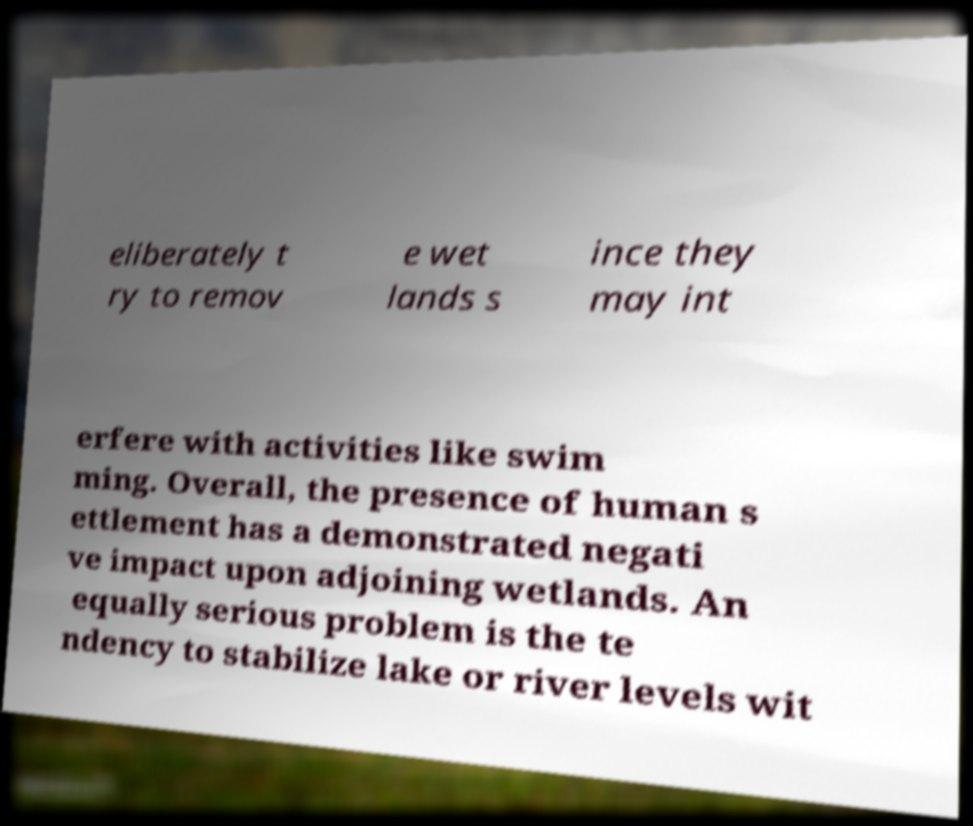Please read and relay the text visible in this image. What does it say? eliberately t ry to remov e wet lands s ince they may int erfere with activities like swim ming. Overall, the presence of human s ettlement has a demonstrated negati ve impact upon adjoining wetlands. An equally serious problem is the te ndency to stabilize lake or river levels wit 